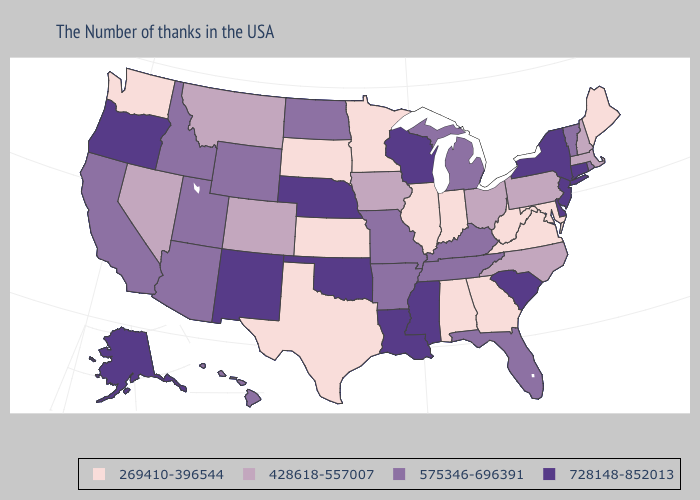Does Michigan have the highest value in the USA?
Write a very short answer. No. Does Idaho have a higher value than New Mexico?
Keep it brief. No. Does Illinois have the lowest value in the USA?
Give a very brief answer. Yes. Does West Virginia have the lowest value in the South?
Keep it brief. Yes. Which states have the lowest value in the West?
Write a very short answer. Washington. What is the lowest value in the USA?
Be succinct. 269410-396544. Name the states that have a value in the range 728148-852013?
Keep it brief. Connecticut, New York, New Jersey, Delaware, South Carolina, Wisconsin, Mississippi, Louisiana, Nebraska, Oklahoma, New Mexico, Oregon, Alaska. What is the value of Florida?
Be succinct. 575346-696391. What is the value of North Dakota?
Quick response, please. 575346-696391. Among the states that border Pennsylvania , which have the highest value?
Keep it brief. New York, New Jersey, Delaware. What is the lowest value in states that border Oregon?
Short answer required. 269410-396544. Which states have the lowest value in the MidWest?
Answer briefly. Indiana, Illinois, Minnesota, Kansas, South Dakota. Among the states that border Maine , which have the lowest value?
Be succinct. New Hampshire. Name the states that have a value in the range 728148-852013?
Short answer required. Connecticut, New York, New Jersey, Delaware, South Carolina, Wisconsin, Mississippi, Louisiana, Nebraska, Oklahoma, New Mexico, Oregon, Alaska. Does Montana have the highest value in the West?
Keep it brief. No. 